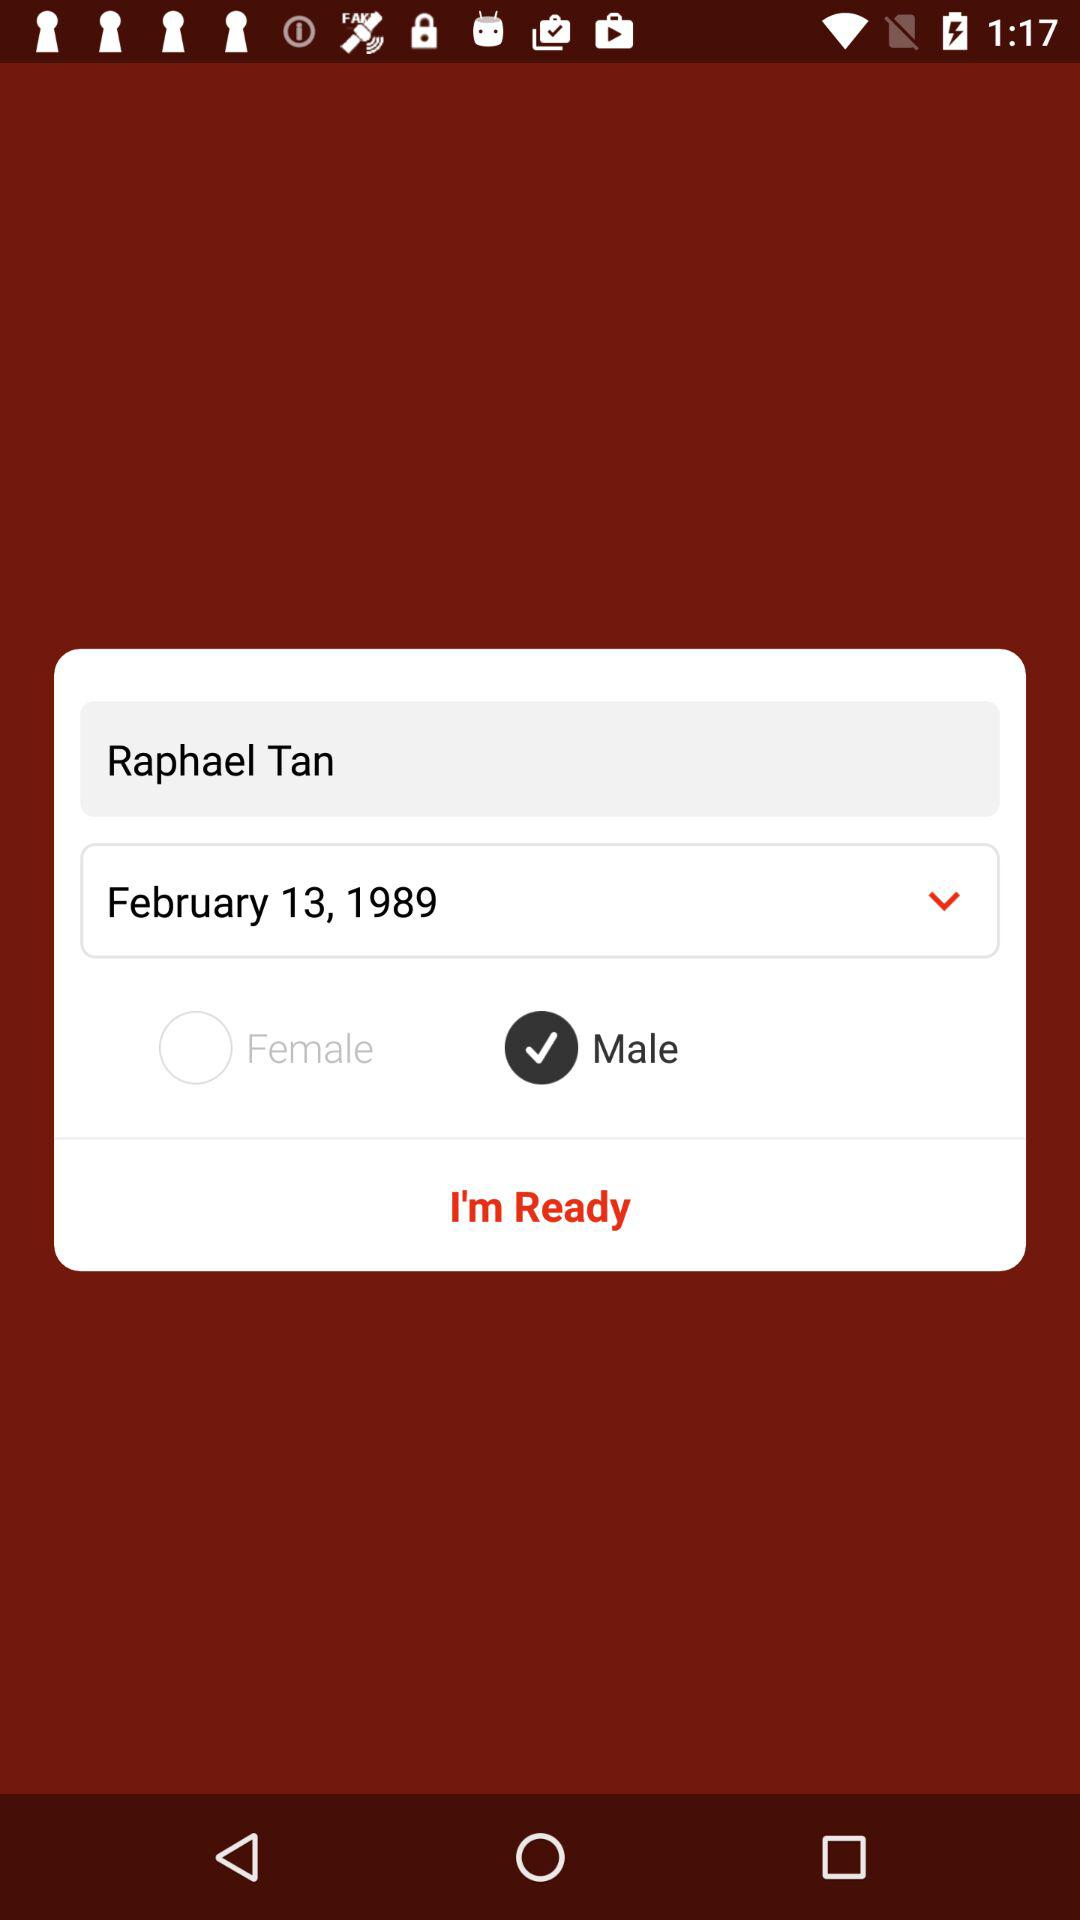What is the name of the application?
When the provided information is insufficient, respond with <no answer>. <no answer> 